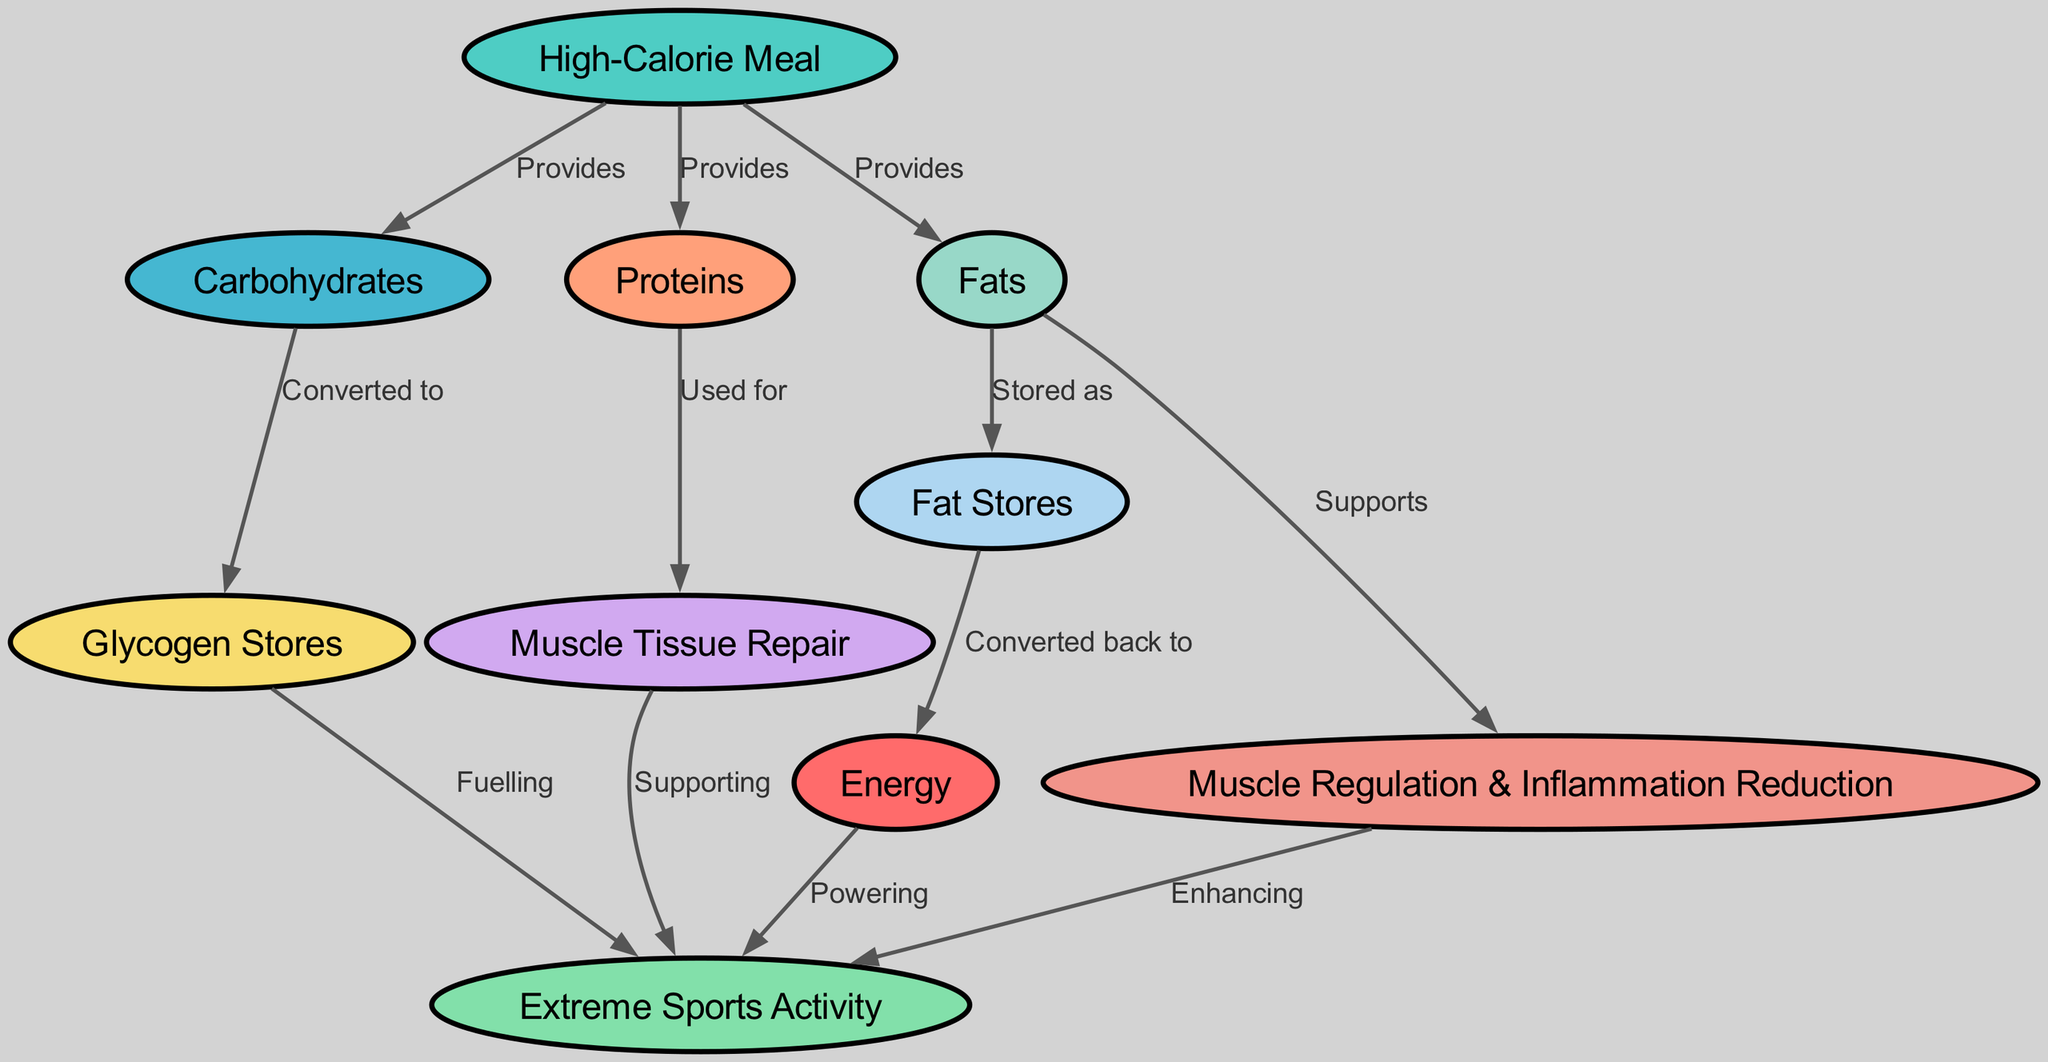What are the three main components of a high-calorie meal? In the diagram, the 'High-Calorie Meal' node provides three components: Carbohydrates, Proteins, and Fats, which are directly connected to it.
Answer: Carbohydrates, Proteins, Fats How many nodes are represented in the diagram? The diagram contains a total of ten nodes, each representing different components and processes involved in energy transfer from a high-calorie meal.
Answer: Ten What is the relationship between carbohydrates and glycogen stores? The diagram shows an edge labeled 'Converted to' from the Carbohydrates node to the Glycogen Stores node, indicating that carbohydrates are transformed into glycogen.
Answer: Converted to Which component supports muscle regulation and inflammation reduction? Fats support the Muscle Regulation & Inflammation Reduction as depicted in the diagram, where there is a direct edge going from the Fats node to the Muscle Regulation & Inflammation Reduction node.
Answer: Fats What is the final result of energy transfer in extreme sports activity? The diagram indicates that energy powers the Extreme Sports Activity, showing a direct connection from the Energy node to the Extreme Sports Activity node.
Answer: Powering How do proteins contribute to extreme sports performance? Proteins are used for Muscle Tissue Repair, and subsequently, muscle tissue repair supports extreme sports activity as indicated by the connections in the diagram.
Answer: Supporting What do fat stores convert back to in the energy transfer process? The diagram specifies that Fat Stores convert back to Energy, creating a connection from the Fat Stores node to the Energy node.
Answer: Converted back to How does a high-calorie meal affect glycogen stores during sports activity? The high-calorie meal provides carbohydrates which are converted into glycogen stores, and glycogen stores are then utilized to fuel extreme sports activity, reflecting a flow from the meal to energy use.
Answer: Fuelling 